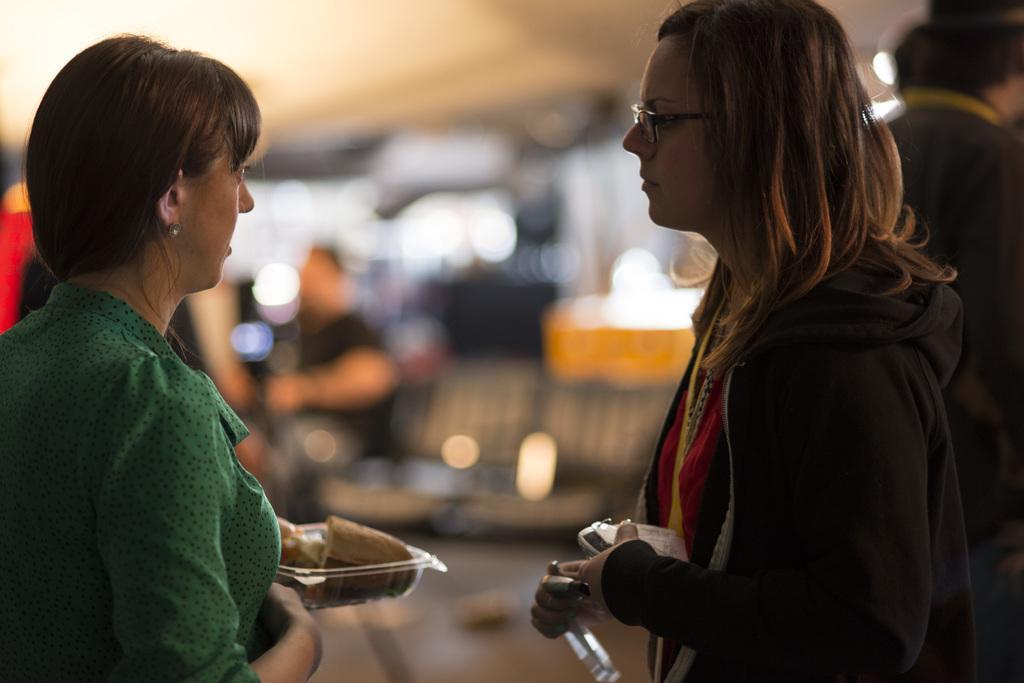Can you describe this image briefly? In the image there are two women standing in front of each other holding box and food plate, behind them there are few persons standing in the background is blurry. 